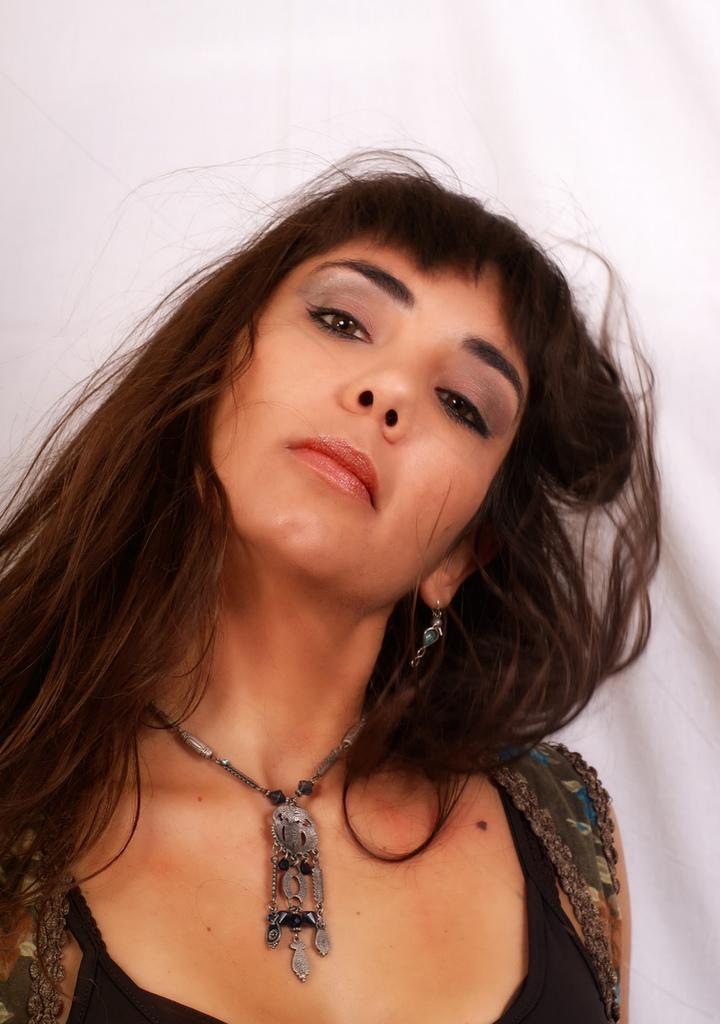Who is the main subject in the image? There is a lady in the center of the image. What can be seen in the background of the image? There is a wall in the background of the image. What type of dog can be seen playing with a leaf in the image? There is no dog or leaf present in the image; it only features a lady and a wall in the background. 